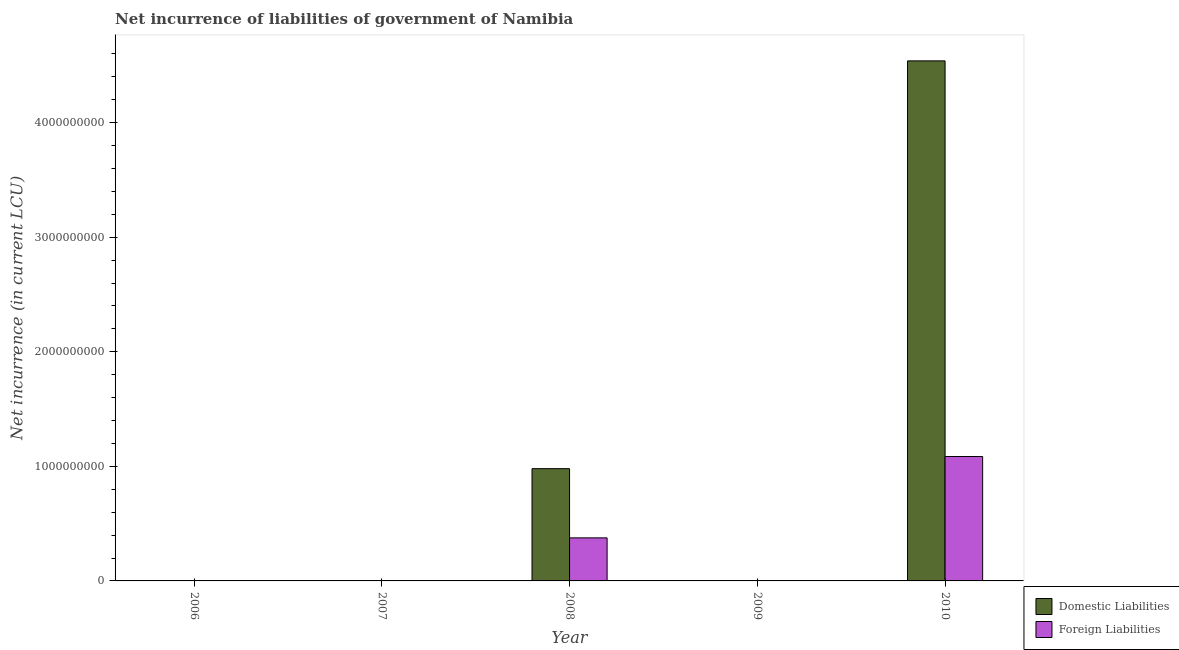Are the number of bars on each tick of the X-axis equal?
Keep it short and to the point. No. How many bars are there on the 2nd tick from the left?
Your answer should be compact. 0. In how many cases, is the number of bars for a given year not equal to the number of legend labels?
Keep it short and to the point. 3. What is the net incurrence of domestic liabilities in 2008?
Provide a succinct answer. 9.80e+08. Across all years, what is the maximum net incurrence of foreign liabilities?
Your answer should be compact. 1.09e+09. Across all years, what is the minimum net incurrence of foreign liabilities?
Give a very brief answer. 0. In which year was the net incurrence of foreign liabilities maximum?
Your response must be concise. 2010. What is the total net incurrence of foreign liabilities in the graph?
Your answer should be very brief. 1.46e+09. What is the difference between the net incurrence of domestic liabilities in 2006 and the net incurrence of foreign liabilities in 2010?
Offer a terse response. -4.54e+09. What is the average net incurrence of domestic liabilities per year?
Offer a very short reply. 1.10e+09. In the year 2010, what is the difference between the net incurrence of foreign liabilities and net incurrence of domestic liabilities?
Your answer should be very brief. 0. Is the difference between the net incurrence of domestic liabilities in 2008 and 2010 greater than the difference between the net incurrence of foreign liabilities in 2008 and 2010?
Offer a very short reply. No. What is the difference between the highest and the lowest net incurrence of domestic liabilities?
Provide a succinct answer. 4.54e+09. In how many years, is the net incurrence of foreign liabilities greater than the average net incurrence of foreign liabilities taken over all years?
Your response must be concise. 2. Is the sum of the net incurrence of foreign liabilities in 2008 and 2010 greater than the maximum net incurrence of domestic liabilities across all years?
Offer a very short reply. Yes. How many bars are there?
Keep it short and to the point. 4. Are all the bars in the graph horizontal?
Give a very brief answer. No. How many years are there in the graph?
Keep it short and to the point. 5. What is the difference between two consecutive major ticks on the Y-axis?
Provide a succinct answer. 1.00e+09. Where does the legend appear in the graph?
Offer a terse response. Bottom right. How are the legend labels stacked?
Ensure brevity in your answer.  Vertical. What is the title of the graph?
Ensure brevity in your answer.  Net incurrence of liabilities of government of Namibia. Does "Investments" appear as one of the legend labels in the graph?
Make the answer very short. No. What is the label or title of the X-axis?
Your answer should be very brief. Year. What is the label or title of the Y-axis?
Your response must be concise. Net incurrence (in current LCU). What is the Net incurrence (in current LCU) in Domestic Liabilities in 2006?
Keep it short and to the point. 0. What is the Net incurrence (in current LCU) of Foreign Liabilities in 2006?
Make the answer very short. 0. What is the Net incurrence (in current LCU) of Domestic Liabilities in 2008?
Ensure brevity in your answer.  9.80e+08. What is the Net incurrence (in current LCU) of Foreign Liabilities in 2008?
Offer a terse response. 3.76e+08. What is the Net incurrence (in current LCU) in Domestic Liabilities in 2009?
Your response must be concise. 0. What is the Net incurrence (in current LCU) of Domestic Liabilities in 2010?
Offer a very short reply. 4.54e+09. What is the Net incurrence (in current LCU) of Foreign Liabilities in 2010?
Your answer should be very brief. 1.09e+09. Across all years, what is the maximum Net incurrence (in current LCU) of Domestic Liabilities?
Provide a short and direct response. 4.54e+09. Across all years, what is the maximum Net incurrence (in current LCU) of Foreign Liabilities?
Your response must be concise. 1.09e+09. Across all years, what is the minimum Net incurrence (in current LCU) of Domestic Liabilities?
Offer a very short reply. 0. Across all years, what is the minimum Net incurrence (in current LCU) of Foreign Liabilities?
Keep it short and to the point. 0. What is the total Net incurrence (in current LCU) of Domestic Liabilities in the graph?
Offer a terse response. 5.52e+09. What is the total Net incurrence (in current LCU) of Foreign Liabilities in the graph?
Your answer should be compact. 1.46e+09. What is the difference between the Net incurrence (in current LCU) in Domestic Liabilities in 2008 and that in 2010?
Make the answer very short. -3.56e+09. What is the difference between the Net incurrence (in current LCU) of Foreign Liabilities in 2008 and that in 2010?
Offer a very short reply. -7.10e+08. What is the difference between the Net incurrence (in current LCU) in Domestic Liabilities in 2008 and the Net incurrence (in current LCU) in Foreign Liabilities in 2010?
Provide a succinct answer. -1.06e+08. What is the average Net incurrence (in current LCU) of Domestic Liabilities per year?
Your answer should be very brief. 1.10e+09. What is the average Net incurrence (in current LCU) of Foreign Liabilities per year?
Provide a short and direct response. 2.92e+08. In the year 2008, what is the difference between the Net incurrence (in current LCU) in Domestic Liabilities and Net incurrence (in current LCU) in Foreign Liabilities?
Your answer should be very brief. 6.04e+08. In the year 2010, what is the difference between the Net incurrence (in current LCU) of Domestic Liabilities and Net incurrence (in current LCU) of Foreign Liabilities?
Make the answer very short. 3.45e+09. What is the ratio of the Net incurrence (in current LCU) of Domestic Liabilities in 2008 to that in 2010?
Make the answer very short. 0.22. What is the ratio of the Net incurrence (in current LCU) of Foreign Liabilities in 2008 to that in 2010?
Offer a terse response. 0.35. What is the difference between the highest and the lowest Net incurrence (in current LCU) in Domestic Liabilities?
Your answer should be compact. 4.54e+09. What is the difference between the highest and the lowest Net incurrence (in current LCU) in Foreign Liabilities?
Provide a short and direct response. 1.09e+09. 